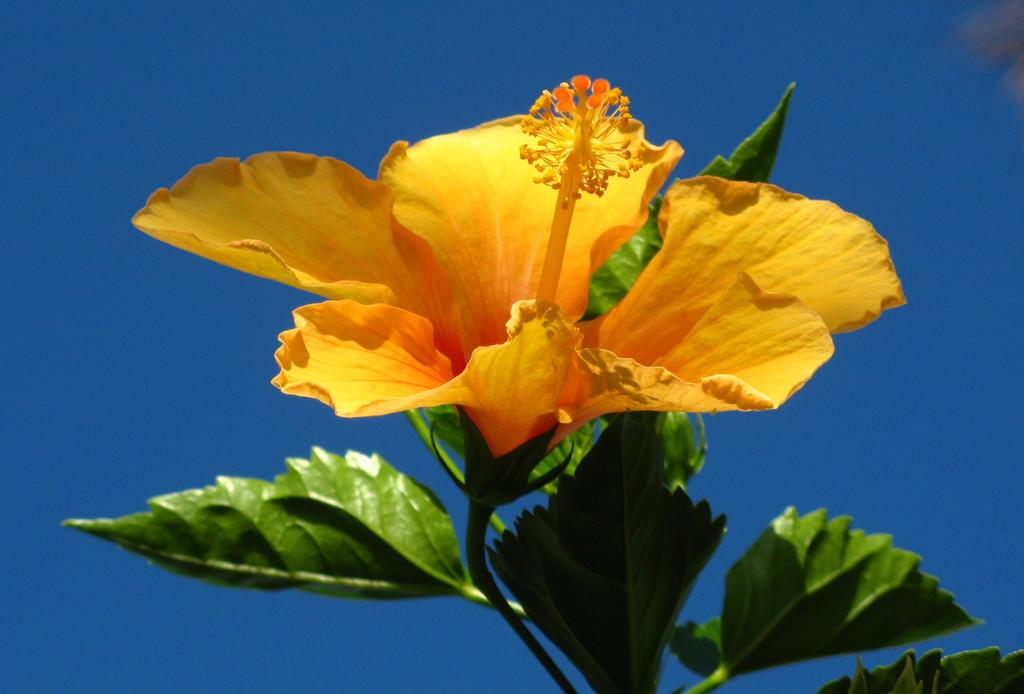What type of plant can be seen in the picture? There is a flower in the picture. What else is present on the plant besides the flower? There are leaves in the picture. What can be seen in the background of the picture? The sky is visible in the background of the picture. What type of caption is written on the flower in the picture? There is no caption written on the flower in the picture. Can you see any sheep in the picture? There are no sheep present in the picture. 